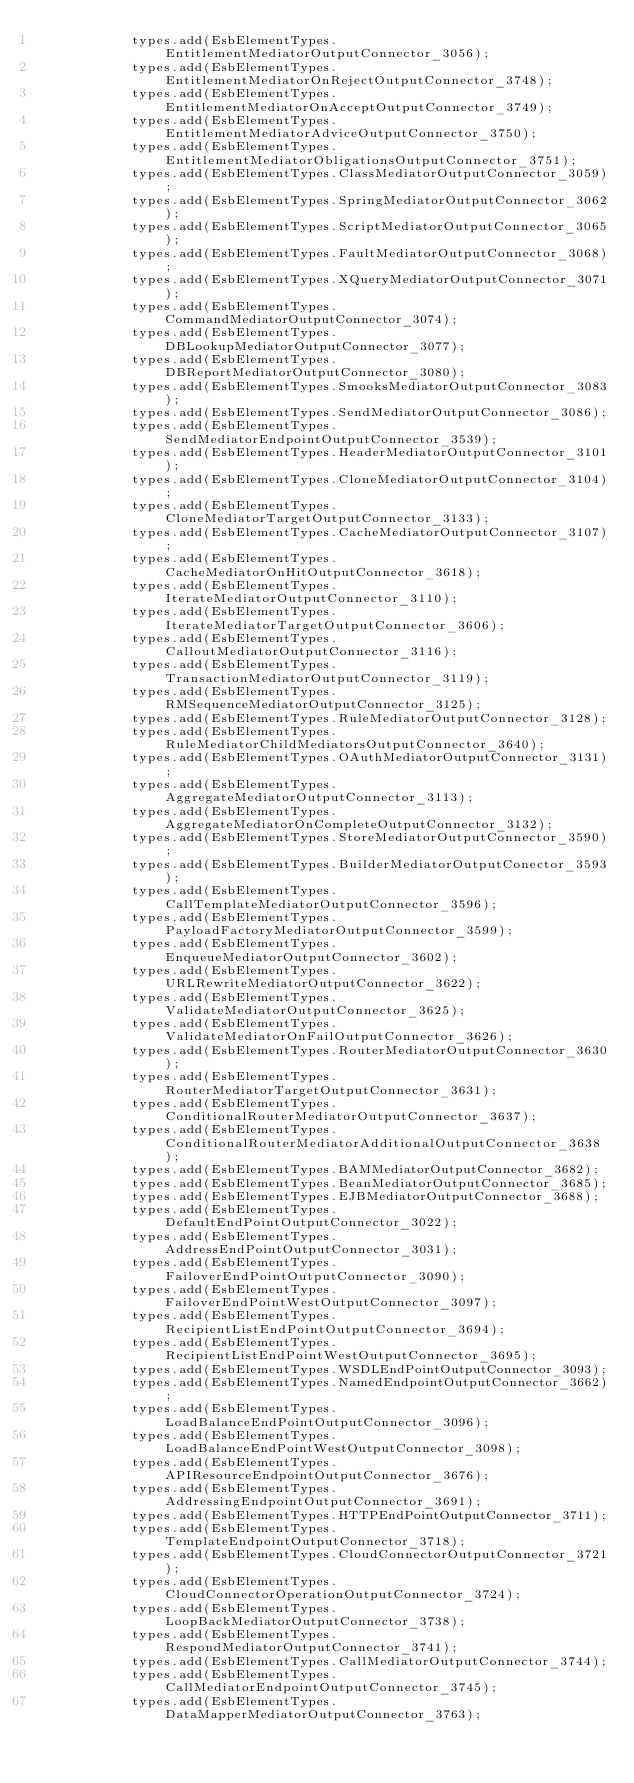Convert code to text. <code><loc_0><loc_0><loc_500><loc_500><_Java_>            types.add(EsbElementTypes.EntitlementMediatorOutputConnector_3056);
            types.add(EsbElementTypes.EntitlementMediatorOnRejectOutputConnector_3748);
            types.add(EsbElementTypes.EntitlementMediatorOnAcceptOutputConnector_3749);
            types.add(EsbElementTypes.EntitlementMediatorAdviceOutputConnector_3750);
            types.add(EsbElementTypes.EntitlementMediatorObligationsOutputConnector_3751);
            types.add(EsbElementTypes.ClassMediatorOutputConnector_3059);
            types.add(EsbElementTypes.SpringMediatorOutputConnector_3062);
            types.add(EsbElementTypes.ScriptMediatorOutputConnector_3065);
            types.add(EsbElementTypes.FaultMediatorOutputConnector_3068);
            types.add(EsbElementTypes.XQueryMediatorOutputConnector_3071);
            types.add(EsbElementTypes.CommandMediatorOutputConnector_3074);
            types.add(EsbElementTypes.DBLookupMediatorOutputConnector_3077);
            types.add(EsbElementTypes.DBReportMediatorOutputConnector_3080);
            types.add(EsbElementTypes.SmooksMediatorOutputConnector_3083);
            types.add(EsbElementTypes.SendMediatorOutputConnector_3086);
            types.add(EsbElementTypes.SendMediatorEndpointOutputConnector_3539);
            types.add(EsbElementTypes.HeaderMediatorOutputConnector_3101);
            types.add(EsbElementTypes.CloneMediatorOutputConnector_3104);
            types.add(EsbElementTypes.CloneMediatorTargetOutputConnector_3133);
            types.add(EsbElementTypes.CacheMediatorOutputConnector_3107);
            types.add(EsbElementTypes.CacheMediatorOnHitOutputConnector_3618);
            types.add(EsbElementTypes.IterateMediatorOutputConnector_3110);
            types.add(EsbElementTypes.IterateMediatorTargetOutputConnector_3606);
            types.add(EsbElementTypes.CalloutMediatorOutputConnector_3116);
            types.add(EsbElementTypes.TransactionMediatorOutputConnector_3119);
            types.add(EsbElementTypes.RMSequenceMediatorOutputConnector_3125);
            types.add(EsbElementTypes.RuleMediatorOutputConnector_3128);
            types.add(EsbElementTypes.RuleMediatorChildMediatorsOutputConnector_3640);
            types.add(EsbElementTypes.OAuthMediatorOutputConnector_3131);
            types.add(EsbElementTypes.AggregateMediatorOutputConnector_3113);
            types.add(EsbElementTypes.AggregateMediatorOnCompleteOutputConnector_3132);
            types.add(EsbElementTypes.StoreMediatorOutputConnector_3590);
            types.add(EsbElementTypes.BuilderMediatorOutputConector_3593);
            types.add(EsbElementTypes.CallTemplateMediatorOutputConnector_3596);
            types.add(EsbElementTypes.PayloadFactoryMediatorOutputConnector_3599);
            types.add(EsbElementTypes.EnqueueMediatorOutputConnector_3602);
            types.add(EsbElementTypes.URLRewriteMediatorOutputConnector_3622);
            types.add(EsbElementTypes.ValidateMediatorOutputConnector_3625);
            types.add(EsbElementTypes.ValidateMediatorOnFailOutputConnector_3626);
            types.add(EsbElementTypes.RouterMediatorOutputConnector_3630);
            types.add(EsbElementTypes.RouterMediatorTargetOutputConnector_3631);
            types.add(EsbElementTypes.ConditionalRouterMediatorOutputConnector_3637);
            types.add(EsbElementTypes.ConditionalRouterMediatorAdditionalOutputConnector_3638);
            types.add(EsbElementTypes.BAMMediatorOutputConnector_3682);
            types.add(EsbElementTypes.BeanMediatorOutputConnector_3685);
            types.add(EsbElementTypes.EJBMediatorOutputConnector_3688);
            types.add(EsbElementTypes.DefaultEndPointOutputConnector_3022);
            types.add(EsbElementTypes.AddressEndPointOutputConnector_3031);
            types.add(EsbElementTypes.FailoverEndPointOutputConnector_3090);
            types.add(EsbElementTypes.FailoverEndPointWestOutputConnector_3097);
            types.add(EsbElementTypes.RecipientListEndPointOutputConnector_3694);
            types.add(EsbElementTypes.RecipientListEndPointWestOutputConnector_3695);
            types.add(EsbElementTypes.WSDLEndPointOutputConnector_3093);
            types.add(EsbElementTypes.NamedEndpointOutputConnector_3662);
            types.add(EsbElementTypes.LoadBalanceEndPointOutputConnector_3096);
            types.add(EsbElementTypes.LoadBalanceEndPointWestOutputConnector_3098);
            types.add(EsbElementTypes.APIResourceEndpointOutputConnector_3676);
            types.add(EsbElementTypes.AddressingEndpointOutputConnector_3691);
            types.add(EsbElementTypes.HTTPEndPointOutputConnector_3711);
            types.add(EsbElementTypes.TemplateEndpointOutputConnector_3718);
            types.add(EsbElementTypes.CloudConnectorOutputConnector_3721);
            types.add(EsbElementTypes.CloudConnectorOperationOutputConnector_3724);
            types.add(EsbElementTypes.LoopBackMediatorOutputConnector_3738);
            types.add(EsbElementTypes.RespondMediatorOutputConnector_3741);
            types.add(EsbElementTypes.CallMediatorOutputConnector_3744);
            types.add(EsbElementTypes.CallMediatorEndpointOutputConnector_3745);
            types.add(EsbElementTypes.DataMapperMediatorOutputConnector_3763);</code> 